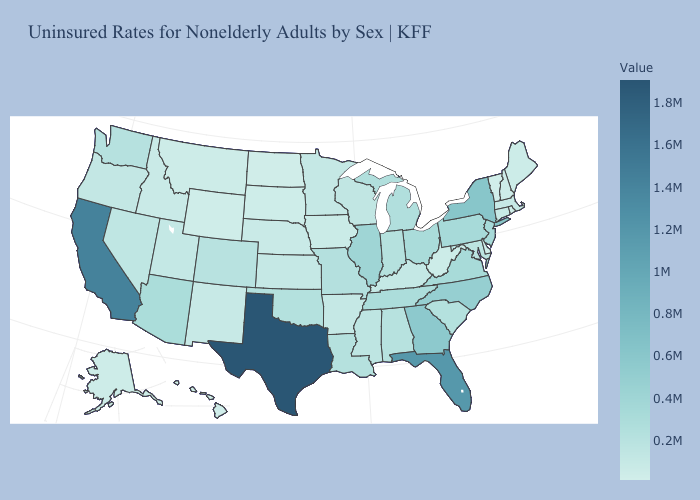Does the map have missing data?
Keep it brief. No. Does Hawaii have the lowest value in the West?
Give a very brief answer. Yes. Which states have the lowest value in the USA?
Concise answer only. Vermont. Does Hawaii have the lowest value in the West?
Be succinct. Yes. Does North Dakota have a lower value than Arizona?
Give a very brief answer. Yes. Among the states that border Utah , which have the highest value?
Give a very brief answer. Arizona. Does California have the highest value in the West?
Concise answer only. Yes. 